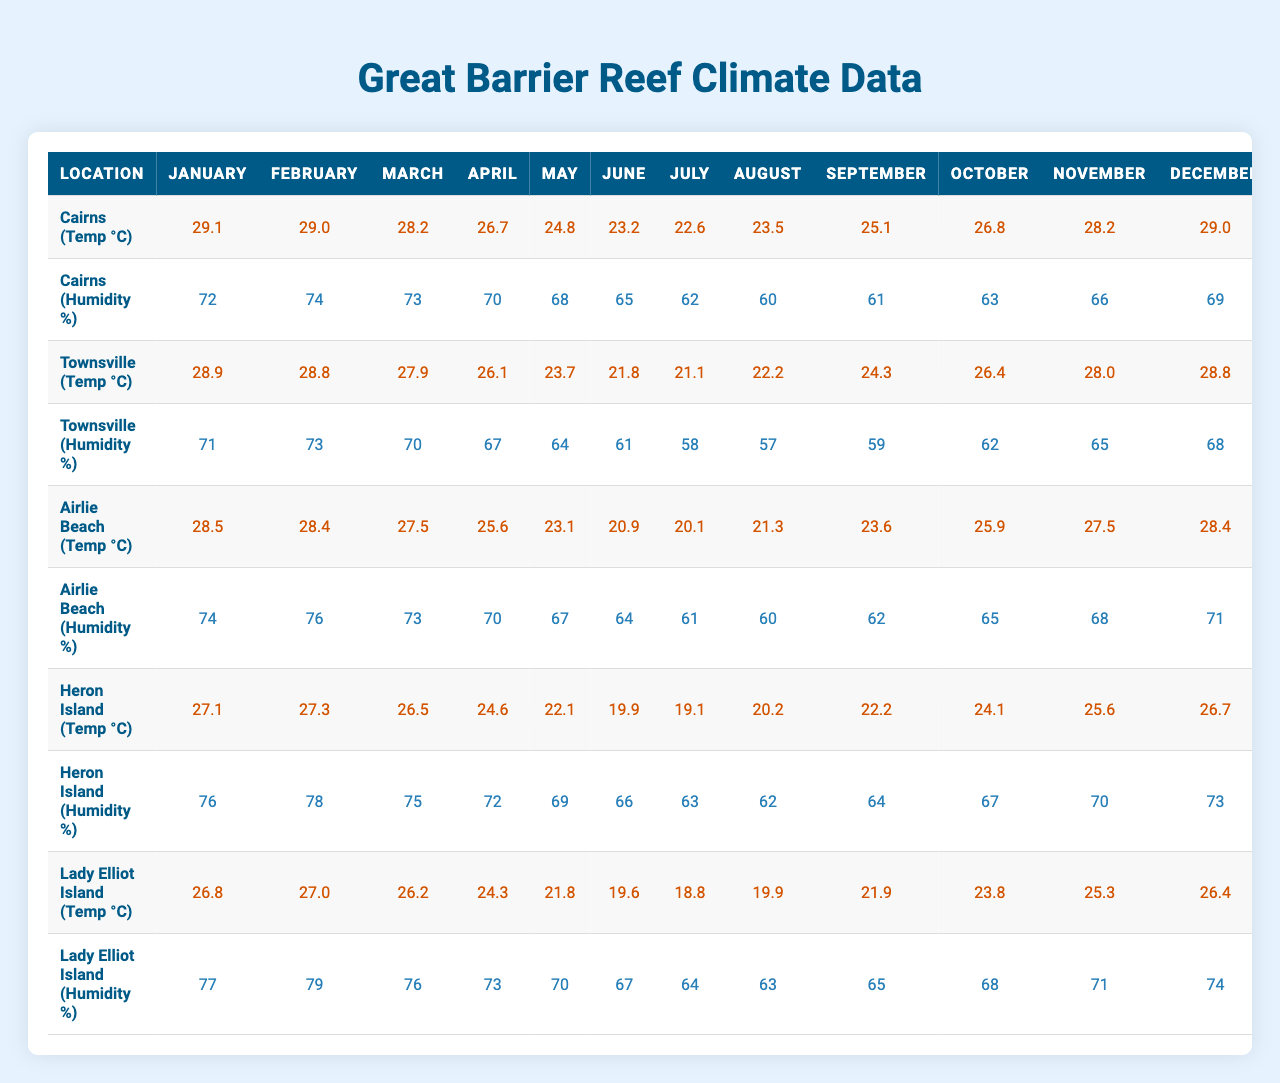What is the highest average temperature recorded in Cairns? The highest average temperature in Cairns can be found by looking at the temperature data for each month. The monthly averages are 29.1, 29.0, 28.2, 26.7, 24.8, 23.2, 22.6, 23.5, 25.1, 26.8, 28.2, and 29.0, with the highest value being 29.1 in January.
Answer: 29.1 Which location has the lowest average humidity in July? To find the lowest average humidity in July, we can look at the humidity data for each location. The values for July are 62, 58, 61, 63, and 64. The lowest value is 58, which corresponds to Townsville.
Answer: Townsville What is the average temperature for Airlie Beach from May to August? The monthly average temperatures for Airlie Beach from May to August are 23.1, 20.9, 20.1, and 21.3. To find the average, we sum these values (23.1 + 20.9 + 20.1 + 21.3) = 85.4 and divide by 4, which gives us 85.4 / 4 = 21.35.
Answer: 21.4 Is the humidity in Heron Island higher than in Lady Elliot Island in December? We need to compare the December humidity values for both locations. The values are 73 for Heron Island and 74 for Lady Elliot Island. Since 73 is less than 74, the statement is false.
Answer: No What month has the most consistent average humidity across all locations? To determine this, we can look for the month that has the smallest range between the highest and lowest humidity values across all locations. Analyzing the data reveals that in June, the humidity values are 65, 61, 64, 66, and 67. The range is 67 - 61 = 6. Checking other months, June has the smallest range, indicating it is the most consistent month.
Answer: June What is the difference in average temperatures between the hottest month in Townsville and the coldest month in Heron Island? For Townsville, the hottest month is January with an average of 28.9, and for Heron Island, the coldest month is July with an average of 19.1. The difference is calculated as 28.9 - 19.1 = 9.8.
Answer: 9.8 How does the average humidity in August for Cairns compare to that of Lady Elliot Island? The average humidity in August for Cairns is 60, while for Lady Elliot Island, it is 63. Comparing these values shows that Lady Elliot Island has a higher humidity level (63 > 60).
Answer: Lady Elliot Island is higher In which month does Airlie Beach experience its lowest average temperature? By checking the monthly average temperatures for Airlie Beach, we see the values are 28.5, 28.4, 27.5, 25.6, 23.1, 20.9, 20.1, 21.3, 23.6, 25.9, 27.5, and 28.4. The lowest average temperature occurs in July, with a value of 20.1.
Answer: July What is the average humidity for the five locations in October? The humidity data for October is 63, 62, 65, 67, and 68 for the respective locations. Summing these values gives 63 + 62 + 65 + 67 + 68 = 325. Dividing by 5 gives an average of 325 / 5 = 65.
Answer: 65 Is the average temperature for Lady Elliot Island higher than 25 degrees in September? The average temperature for Lady Elliot Island in September is 21.9, which is less than 25 degrees. Therefore, the statement is false.
Answer: No 